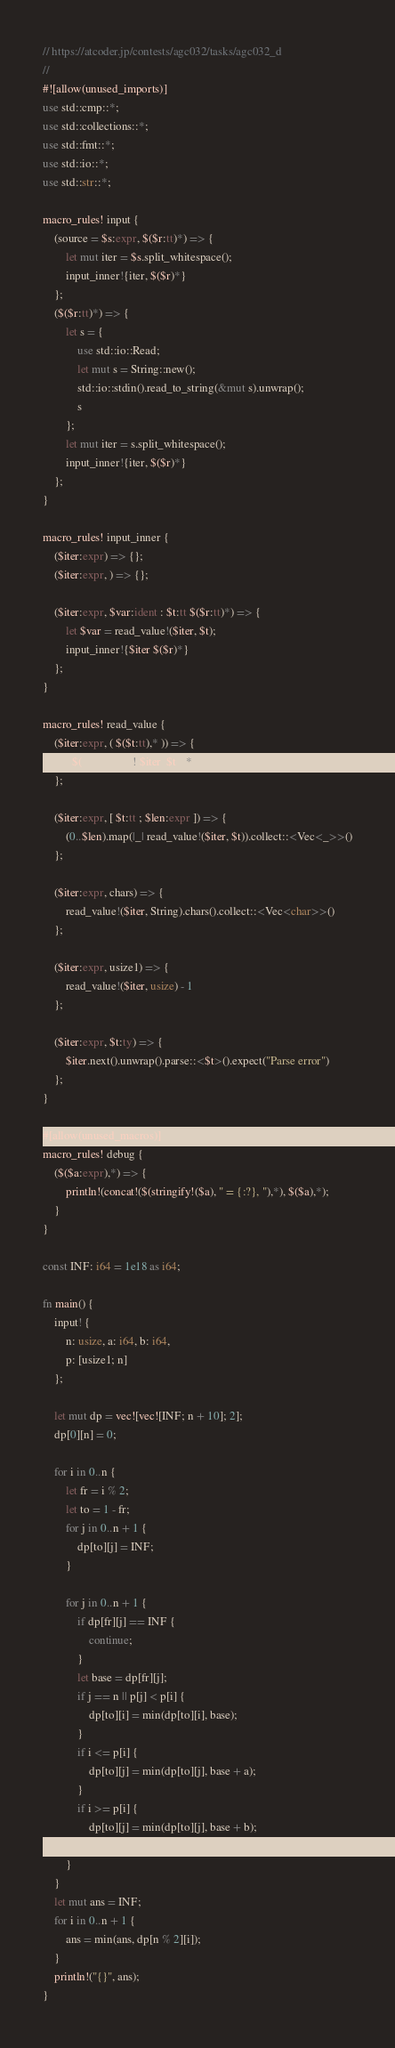Convert code to text. <code><loc_0><loc_0><loc_500><loc_500><_Rust_>// https://atcoder.jp/contests/agc032/tasks/agc032_d
//
#![allow(unused_imports)]
use std::cmp::*;
use std::collections::*;
use std::fmt::*;
use std::io::*;
use std::str::*;

macro_rules! input {
    (source = $s:expr, $($r:tt)*) => {
        let mut iter = $s.split_whitespace();
        input_inner!{iter, $($r)*}
    };
    ($($r:tt)*) => {
        let s = {
            use std::io::Read;
            let mut s = String::new();
            std::io::stdin().read_to_string(&mut s).unwrap();
            s
        };
        let mut iter = s.split_whitespace();
        input_inner!{iter, $($r)*}
    };
}

macro_rules! input_inner {
    ($iter:expr) => {};
    ($iter:expr, ) => {};

    ($iter:expr, $var:ident : $t:tt $($r:tt)*) => {
        let $var = read_value!($iter, $t);
        input_inner!{$iter $($r)*}
    };
}

macro_rules! read_value {
    ($iter:expr, ( $($t:tt),* )) => {
        ( $(read_value!($iter, $t)),* )
    };

    ($iter:expr, [ $t:tt ; $len:expr ]) => {
        (0..$len).map(|_| read_value!($iter, $t)).collect::<Vec<_>>()
    };

    ($iter:expr, chars) => {
        read_value!($iter, String).chars().collect::<Vec<char>>()
    };

    ($iter:expr, usize1) => {
        read_value!($iter, usize) - 1
    };

    ($iter:expr, $t:ty) => {
        $iter.next().unwrap().parse::<$t>().expect("Parse error")
    };
}

#[allow(unused_macros)]
macro_rules! debug {
    ($($a:expr),*) => {
        println!(concat!($(stringify!($a), " = {:?}, "),*), $($a),*);
    }
}

const INF: i64 = 1e18 as i64;

fn main() {
    input! {
        n: usize, a: i64, b: i64,
        p: [usize1; n]
    };

    let mut dp = vec![vec![INF; n + 10]; 2];
    dp[0][n] = 0;

    for i in 0..n {
        let fr = i % 2;
        let to = 1 - fr;
        for j in 0..n + 1 {
            dp[to][j] = INF;
        }

        for j in 0..n + 1 {
            if dp[fr][j] == INF {
                continue;
            }
            let base = dp[fr][j];
            if j == n || p[j] < p[i] {
                dp[to][i] = min(dp[to][i], base);
            }
            if i <= p[i] {
                dp[to][j] = min(dp[to][j], base + a);
            }
            if i >= p[i] {
                dp[to][j] = min(dp[to][j], base + b);
            }
        }
    }
    let mut ans = INF;
    for i in 0..n + 1 {
        ans = min(ans, dp[n % 2][i]);
    }
    println!("{}", ans);
}
</code> 